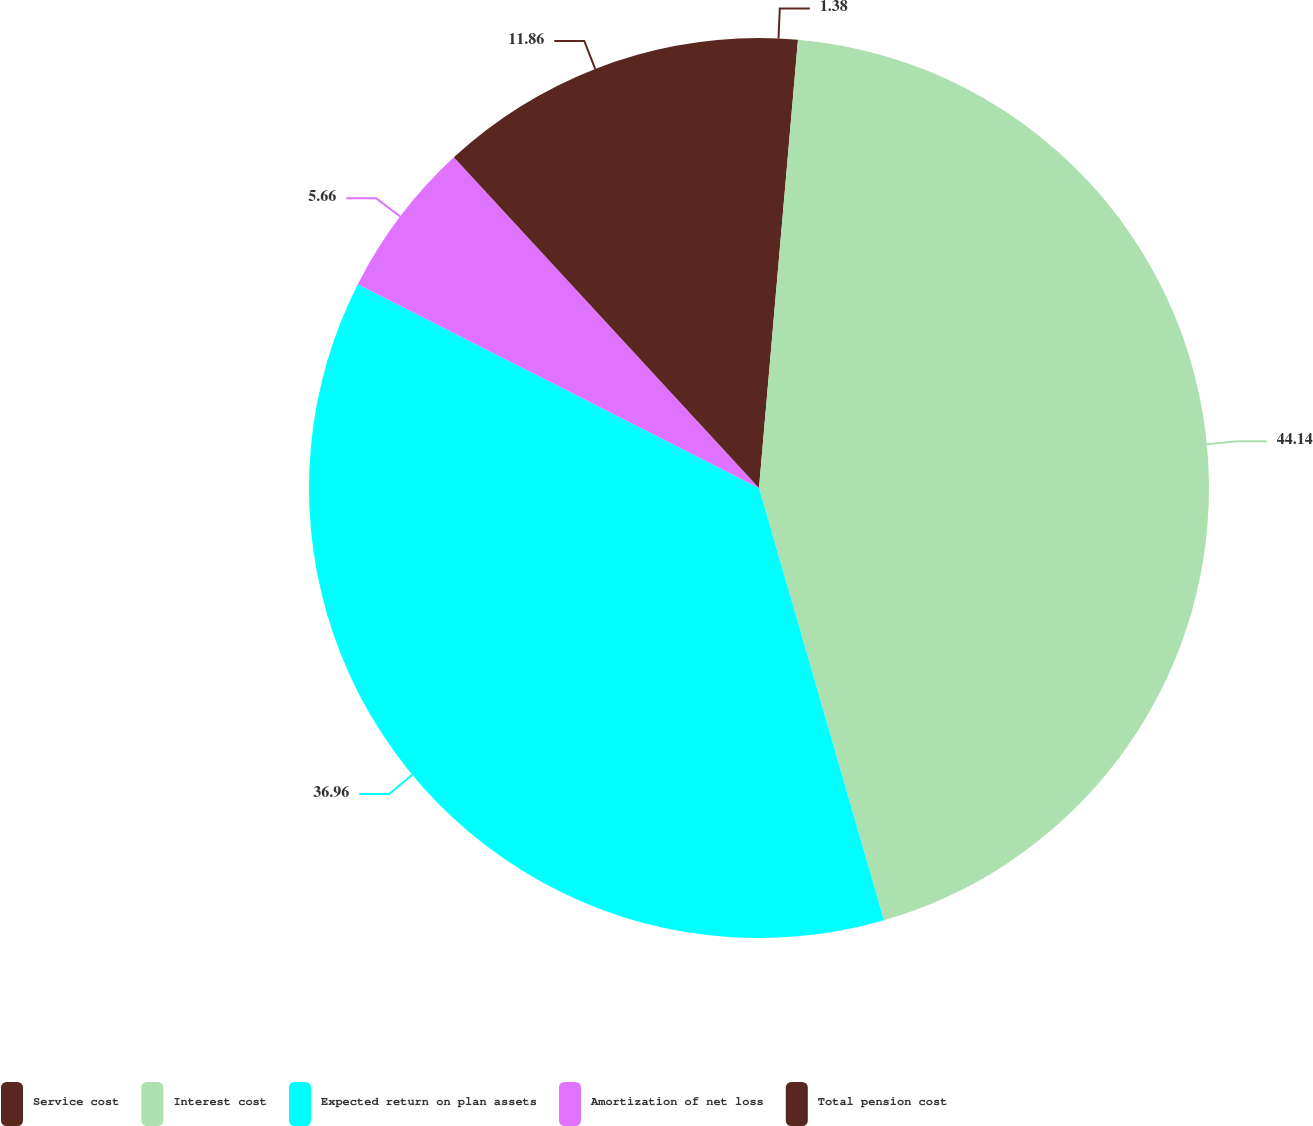Convert chart. <chart><loc_0><loc_0><loc_500><loc_500><pie_chart><fcel>Service cost<fcel>Interest cost<fcel>Expected return on plan assets<fcel>Amortization of net loss<fcel>Total pension cost<nl><fcel>1.38%<fcel>44.14%<fcel>36.96%<fcel>5.66%<fcel>11.86%<nl></chart> 